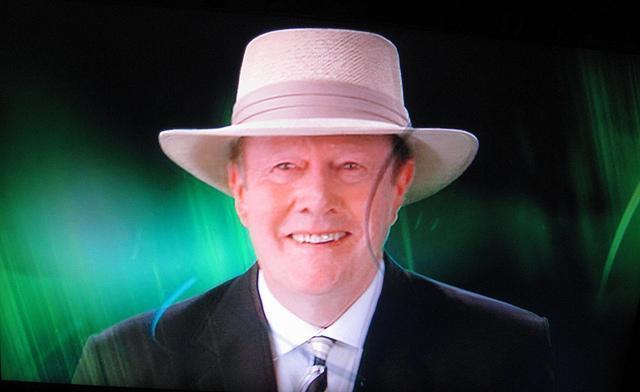How many people are there?
Give a very brief answer. 1. 